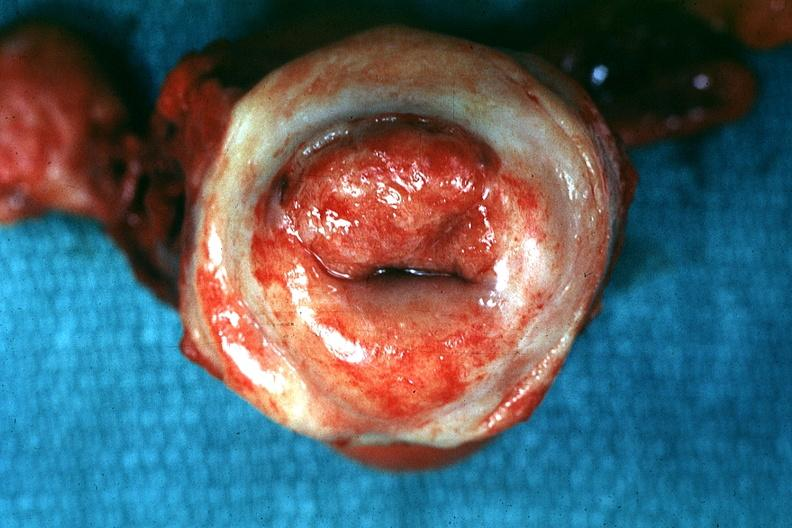what is present?
Answer the question using a single word or phrase. Female reproductive 